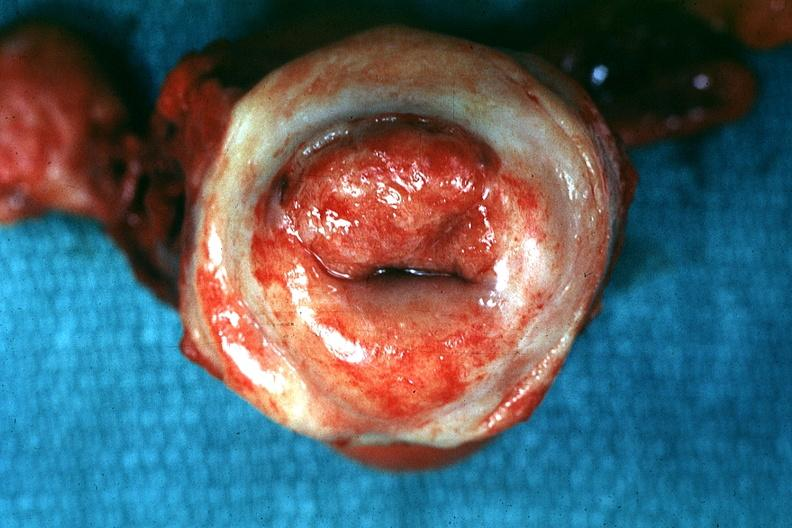what is present?
Answer the question using a single word or phrase. Female reproductive 